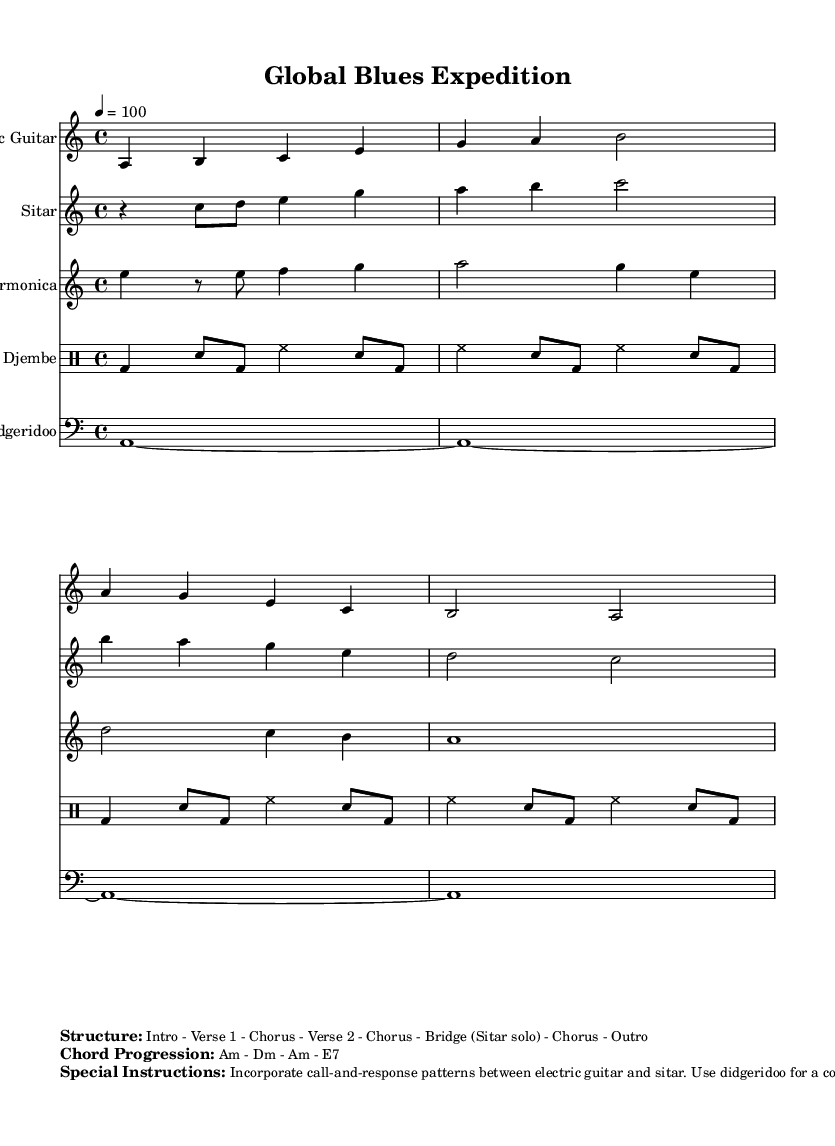What is the key signature of this music? The key signature is indicated in the global settings of the sheet music, which specifies A minor. A minor has no sharps or flats.
Answer: A minor What is the time signature of the piece? The time signature is explicitly stated in the global settings as 4/4, meaning there are four beats per measure.
Answer: 4/4 What tempo marking is indicated in the music? The tempo marking given in the global settings is 4 = 100, which indicates that there are 100 beats per minute.
Answer: 100 Which instrument plays the solo in the bridge section? The special instructions state that the bridge features a sitar solo, highlighting its prominence during that section.
Answer: Sitar What is the chord progression used in the piece? The chord progression is provided in the markup section, detailing the sequence of chords to be played throughout the music. It reads Am - Dm - Am - E7.
Answer: Am - Dm - Am - E7 How should the electric guitar and sitar interact according to the special instructions? The special instructions emphasize a call-and-response pattern between the electric guitar and the sitar, indicating their interactive improvisational style.
Answer: Call-and-response What rhythm does the djembe provide in the music? The special instructions describe the djembe as providing syncopated rhythms that complement the blues shuffle, thus enhancing the overall groove of the piece.
Answer: Syncopated rhythms 